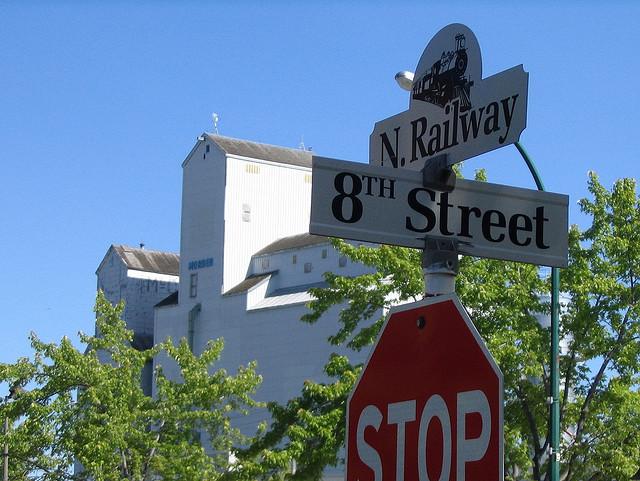Which way is the stop sign facing?
Short answer required. Left. How many street signs do you see?
Keep it brief. 2. What streets are these?
Quick response, please. N railway and 8th. 